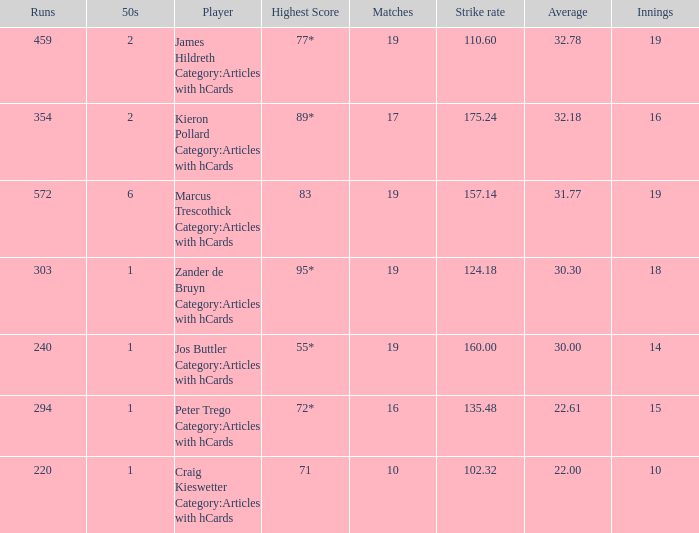What is the highest score for the player with average of 30.00? 55*. 